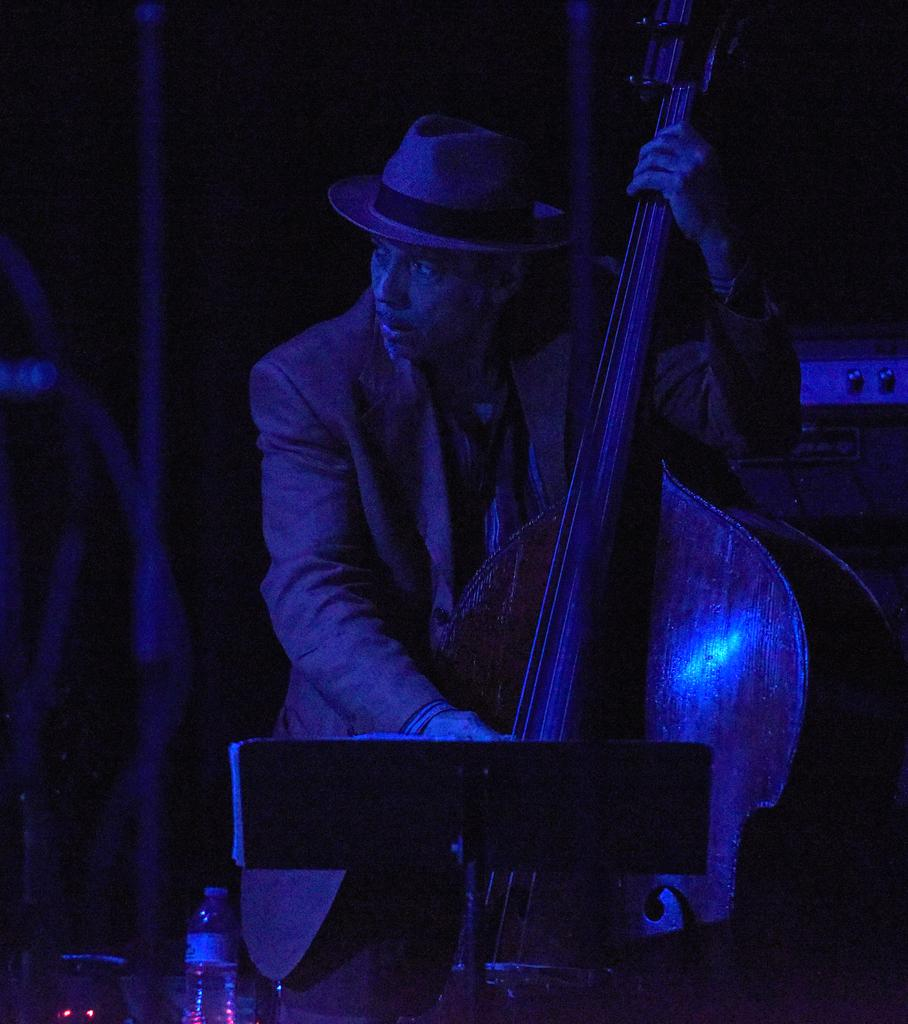What is the main subject of the image? The main subject of the image is a man. What is the man holding in the image? The man is holding a musical instrument. Can you describe the man's attire in the image? The man is wearing a cap. What other objects can be seen in the image? There is a bottle and a stand in the image. Can you provide an example of a hydrant in the image? There is no hydrant present in the image. How many numbers are visible on the musical instrument in the image? There is no information about numbers on the musical instrument in the image. 